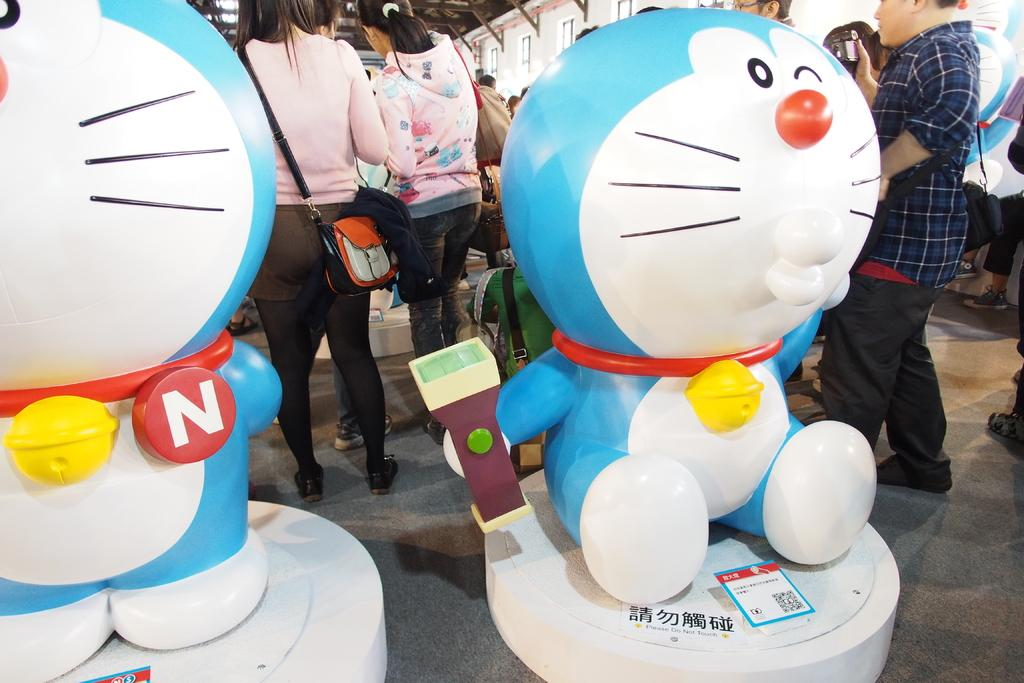What objects can be seen in the image? There are toys in the image. What additional detail can be observed in the image? There is a barcode in the image. What can be seen in the background of the image? In the background, there are people wearing bags. What type of vein can be seen in the image? There is no vein present in the image. What are the people in the image learning? The image does not provide information about what the people are learning. 